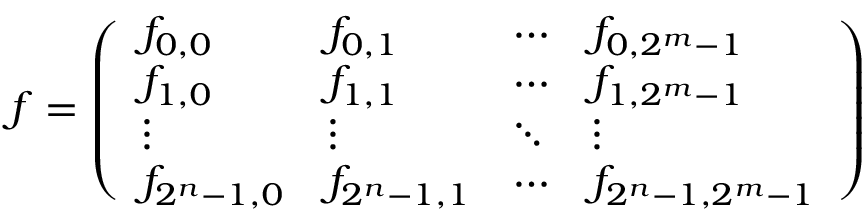<formula> <loc_0><loc_0><loc_500><loc_500>{ \boldsymbol f } = \left ( \begin{array} { l l l l } { f _ { 0 , 0 } } & { f _ { 0 , 1 } } & { \cdots } & { f _ { 0 , 2 ^ { m } - 1 } } \\ { f _ { 1 , 0 } } & { f _ { 1 , 1 } } & { \cdots } & { f _ { 1 , 2 ^ { m } - 1 } } \\ { \vdots } & { \vdots } & { \ddots } & { \vdots } \\ { f _ { 2 ^ { n } - 1 , 0 } } & { f _ { 2 ^ { n } - 1 , 1 } } & { \cdots } & { f _ { 2 ^ { n } - 1 , 2 ^ { m } - 1 } } \end{array} \right )</formula> 